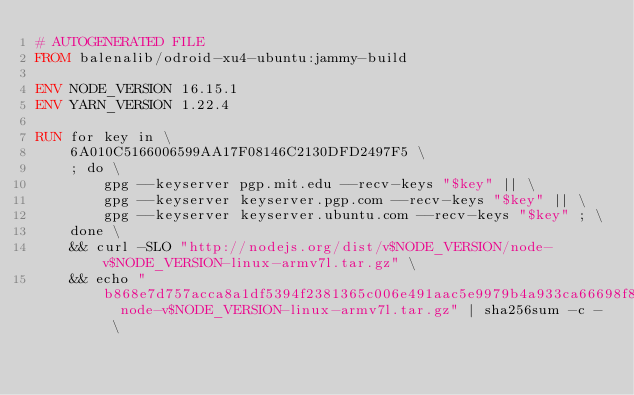Convert code to text. <code><loc_0><loc_0><loc_500><loc_500><_Dockerfile_># AUTOGENERATED FILE
FROM balenalib/odroid-xu4-ubuntu:jammy-build

ENV NODE_VERSION 16.15.1
ENV YARN_VERSION 1.22.4

RUN for key in \
	6A010C5166006599AA17F08146C2130DFD2497F5 \
	; do \
		gpg --keyserver pgp.mit.edu --recv-keys "$key" || \
		gpg --keyserver keyserver.pgp.com --recv-keys "$key" || \
		gpg --keyserver keyserver.ubuntu.com --recv-keys "$key" ; \
	done \
	&& curl -SLO "http://nodejs.org/dist/v$NODE_VERSION/node-v$NODE_VERSION-linux-armv7l.tar.gz" \
	&& echo "b868e7d757acca8a1df5394f2381365c006e491aac5e9979b4a933ca66698f8c  node-v$NODE_VERSION-linux-armv7l.tar.gz" | sha256sum -c - \</code> 